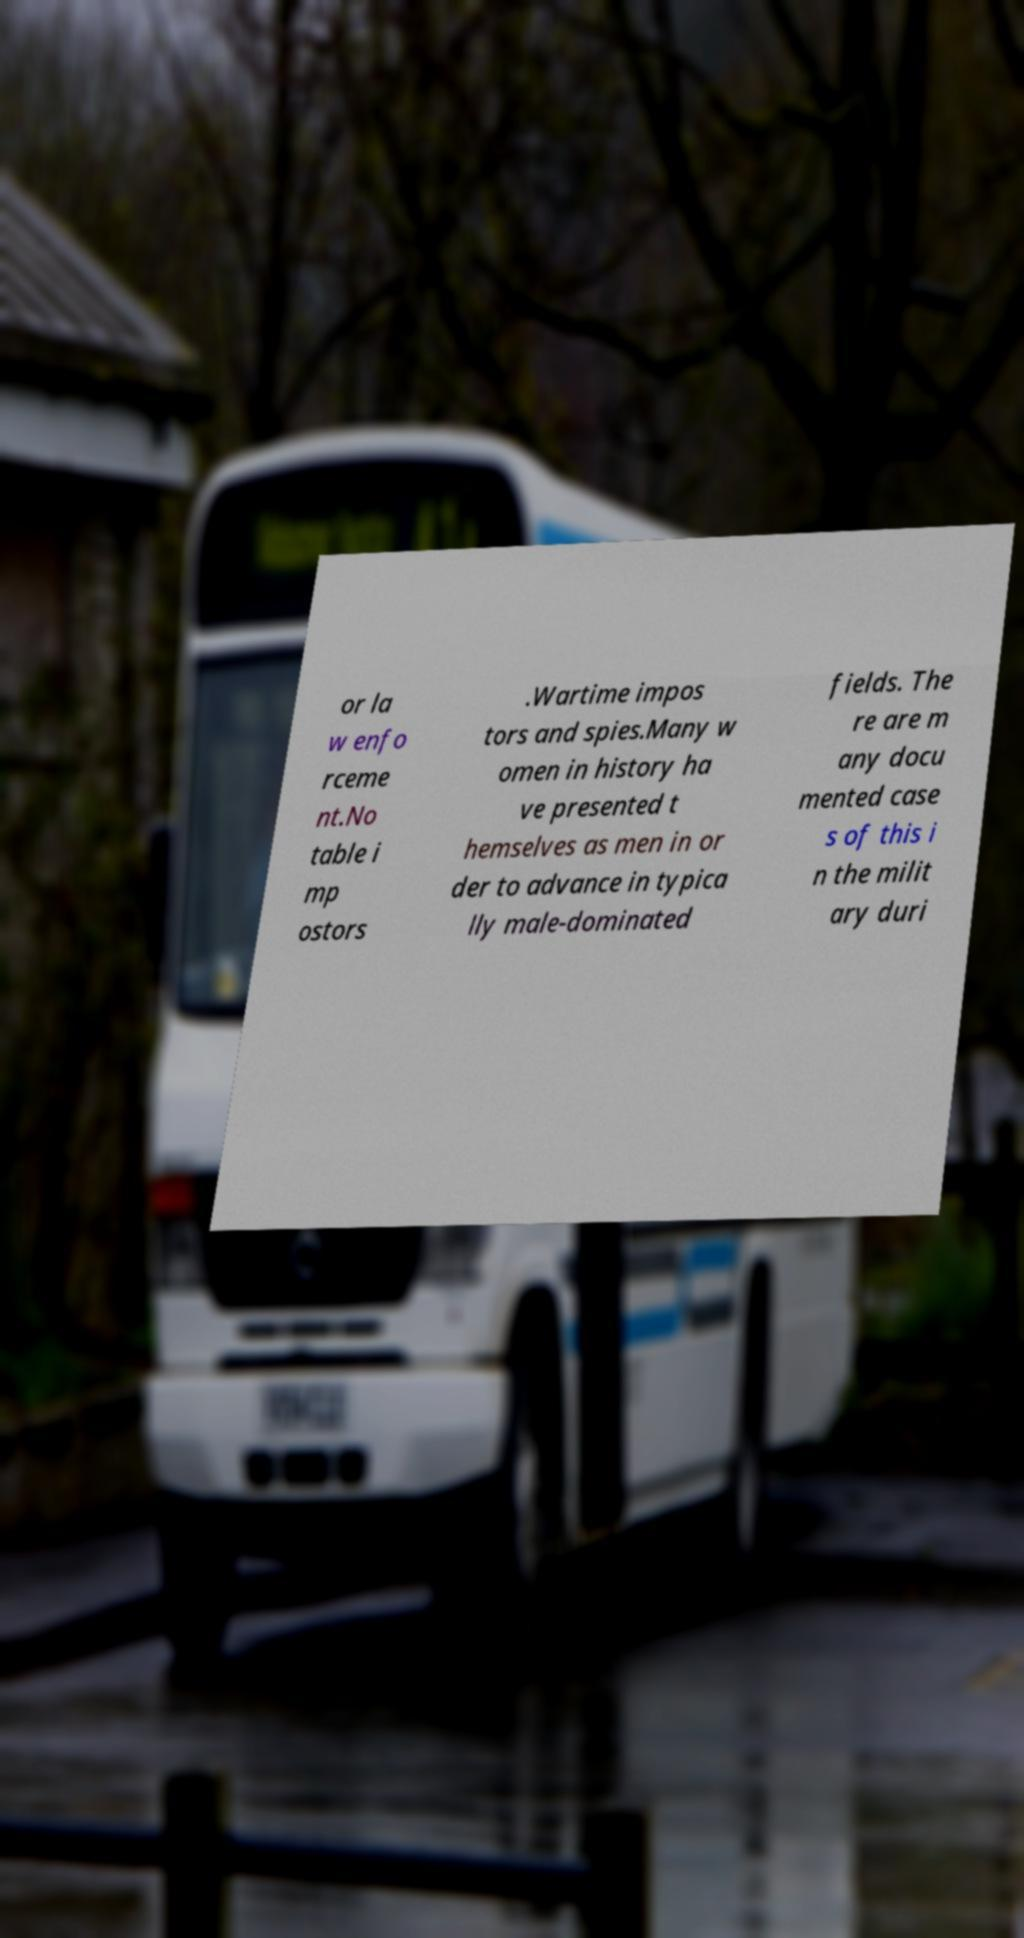Please identify and transcribe the text found in this image. or la w enfo rceme nt.No table i mp ostors .Wartime impos tors and spies.Many w omen in history ha ve presented t hemselves as men in or der to advance in typica lly male-dominated fields. The re are m any docu mented case s of this i n the milit ary duri 